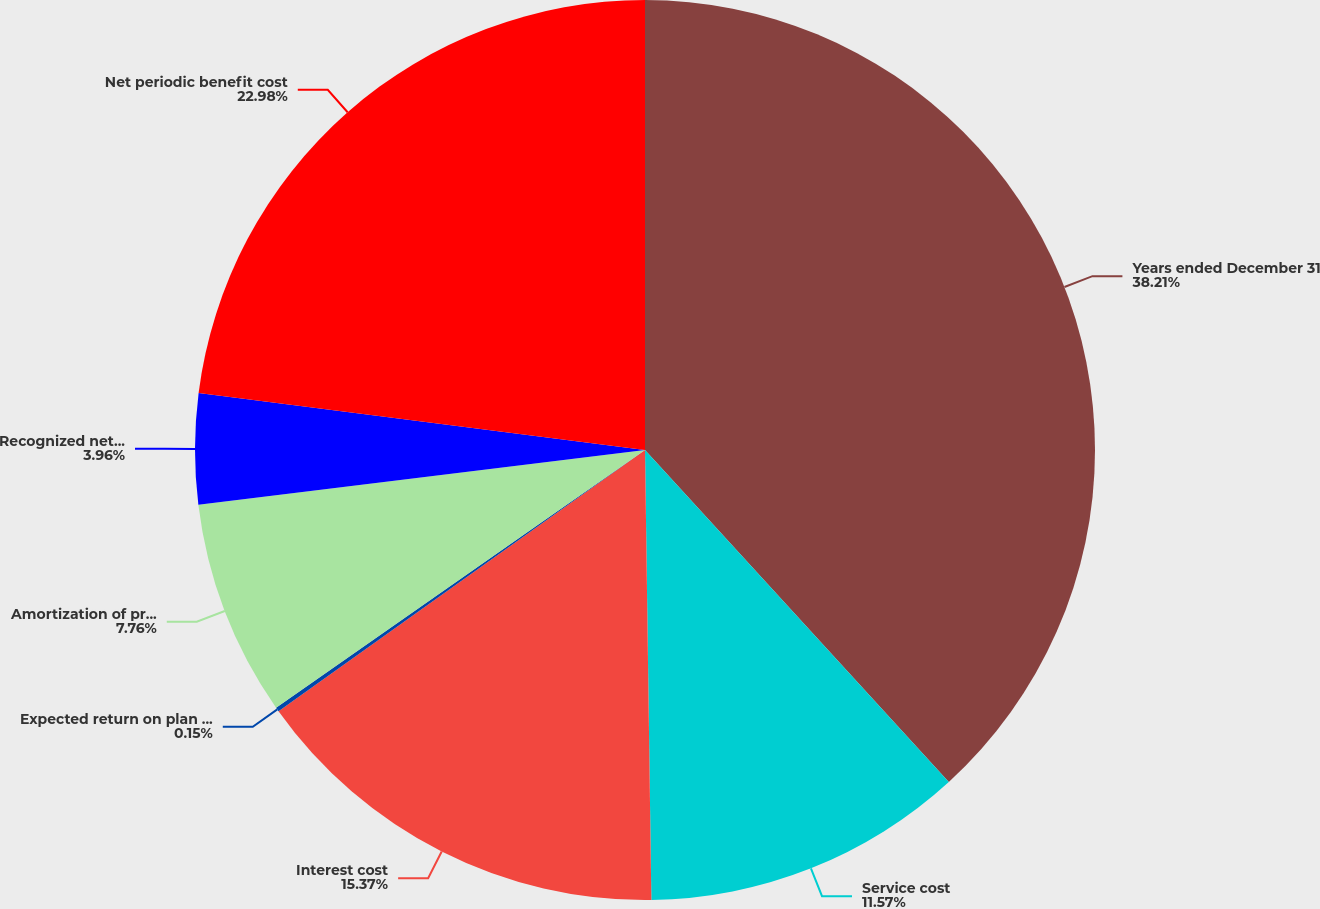<chart> <loc_0><loc_0><loc_500><loc_500><pie_chart><fcel>Years ended December 31<fcel>Service cost<fcel>Interest cost<fcel>Expected return on plan assets<fcel>Amortization of prior service<fcel>Recognized net actuarial loss<fcel>Net periodic benefit cost<nl><fcel>38.2%<fcel>11.57%<fcel>15.37%<fcel>0.15%<fcel>7.76%<fcel>3.96%<fcel>22.98%<nl></chart> 